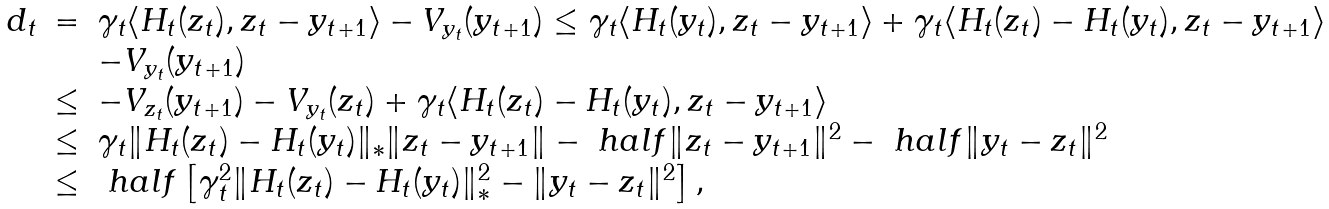<formula> <loc_0><loc_0><loc_500><loc_500>\begin{array} { r c l } d _ { t } & = & \gamma _ { t } \langle H _ { t } ( z _ { t } ) , z _ { t } - y _ { t + 1 } \rangle - V _ { y _ { t } } ( y _ { t + 1 } ) \leq \gamma _ { t } \langle H _ { t } ( y _ { t } ) , z _ { t } - y _ { t + 1 } \rangle + \gamma _ { t } \langle H _ { t } ( z _ { t } ) - H _ { t } ( y _ { t } ) , z _ { t } - y _ { t + 1 } \rangle \\ & & - V _ { y _ { t } } ( y _ { t + 1 } ) \\ & \leq & - V _ { z _ { t } } ( y _ { t + 1 } ) - V _ { y _ { t } } ( z _ { t } ) + \gamma _ { t } \langle H _ { t } ( z _ { t } ) - H _ { t } ( y _ { t } ) , z _ { t } - y _ { t + 1 } \rangle \\ & \leq & \gamma _ { t } \| H _ { t } ( z _ { t } ) - H _ { t } ( y _ { t } ) \| _ { * } \| z _ { t } - y _ { t + 1 } \| - { \ h a l f } \| z _ { t } - y _ { t + 1 } \| ^ { 2 } - { \ h a l f } \| y _ { t } - z _ { t } \| ^ { 2 } \\ & \leq & { \ h a l f } \left [ \gamma _ { t } ^ { 2 } \| H _ { t } ( z _ { t } ) - H _ { t } ( y _ { t } ) \| _ { * } ^ { 2 } - \| y _ { t } - z _ { t } \| ^ { 2 } \right ] , \\ \end{array}</formula> 